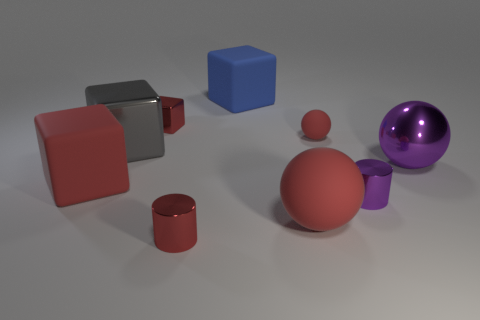Can you tell which object is the largest? Among all the objects, the orange sphere seems to be the largest when comparing the visible dimensions in the image, given the perspective from which the image is taken. 